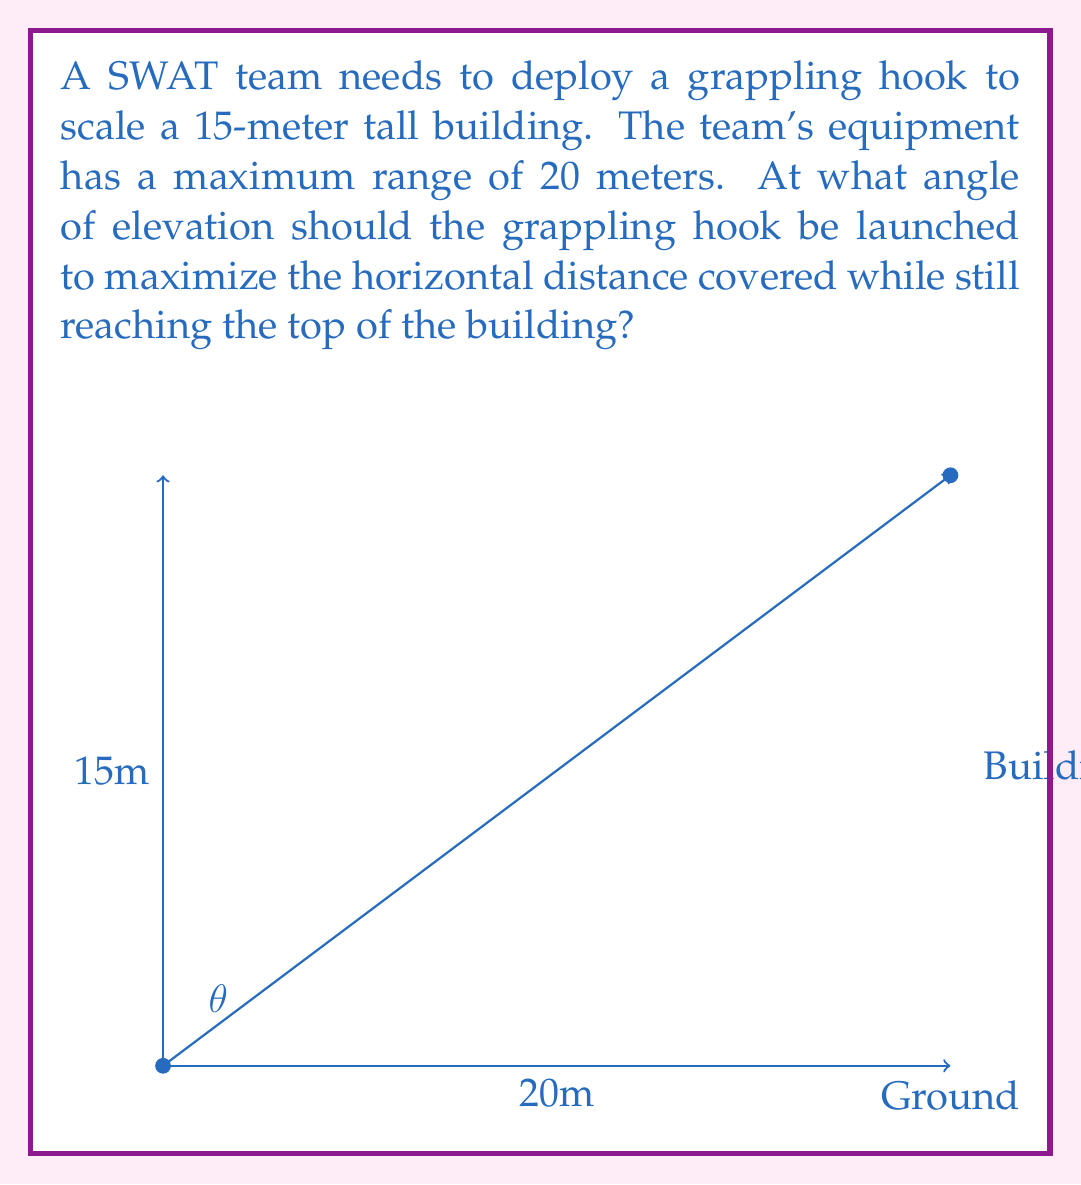Could you help me with this problem? Let's approach this step-by-step using trigonometric functions:

1) Let $\theta$ be the angle of elevation. We need to maximize the horizontal distance ($x$) while ensuring the vertical distance reaches 15 meters.

2) We can use the equations:
   $$\tan(\theta) = \frac{15}{x}$$
   $$x^2 + 15^2 = 20^2$$ (Pythagorean theorem)

3) From the second equation:
   $$x^2 = 400 - 225 = 175$$
   $$x = \sqrt{175} \approx 13.23$$

4) Now we can find $\theta$:
   $$\theta = \arctan(\frac{15}{x}) = \arctan(\frac{15}{\sqrt{175}})$$

5) To calculate this:
   $$\theta = \arctan(\frac{15}{\sqrt{175}}) \approx 0.8481 \text{ radians}$$

6) Convert to degrees:
   $$\theta \approx 0.8481 \times \frac{180}{\pi} \approx 48.59°$$

Therefore, the optimal angle to launch the grappling hook is approximately 48.59° from the horizontal.
Answer: The optimal angle for deploying the grappling hook is approximately $48.59°$ from the horizontal. 